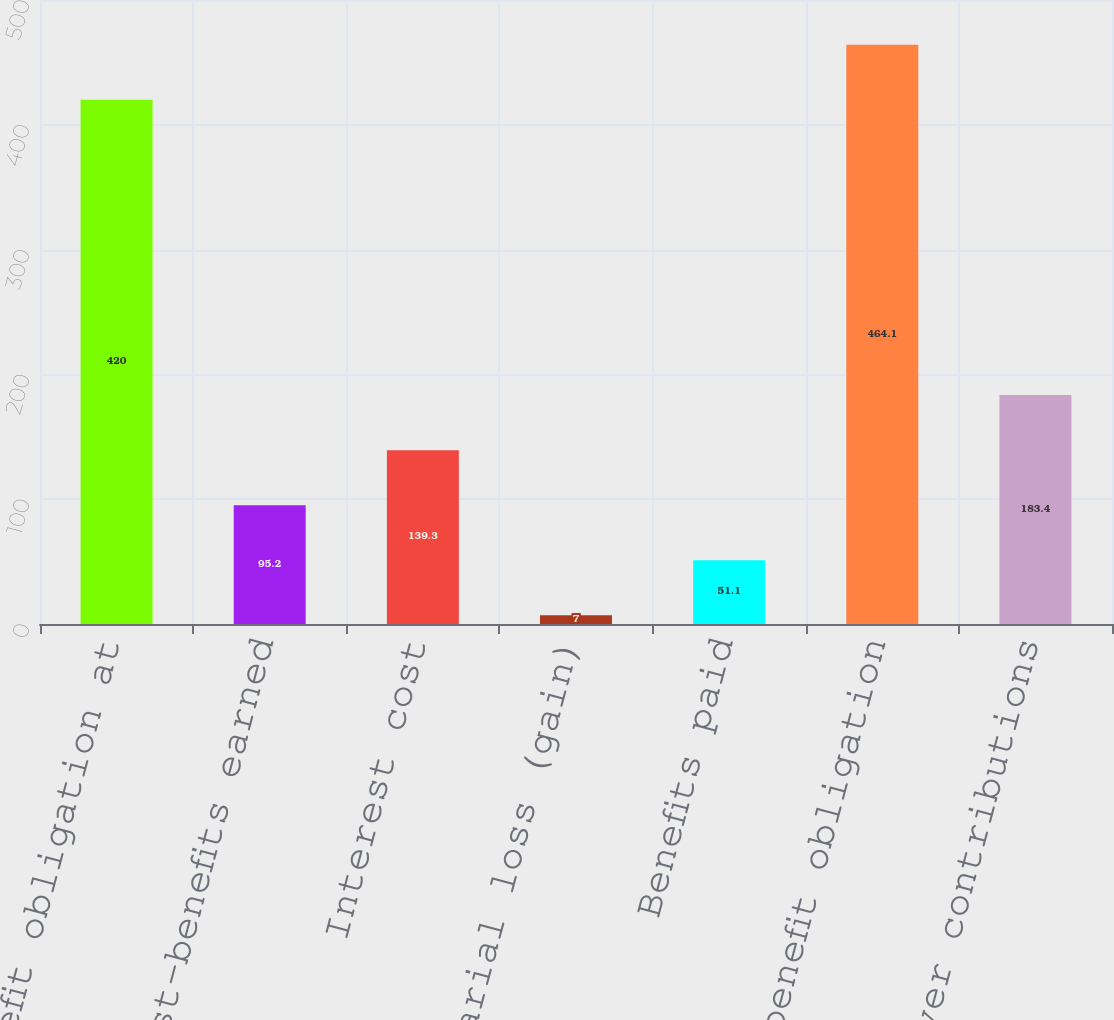Convert chart to OTSL. <chart><loc_0><loc_0><loc_500><loc_500><bar_chart><fcel>Benefit obligation at<fcel>Service cost-benefits earned<fcel>Interest cost<fcel>Actuarial loss (gain)<fcel>Benefits paid<fcel>Projected benefit obligation<fcel>Employer contributions<nl><fcel>420<fcel>95.2<fcel>139.3<fcel>7<fcel>51.1<fcel>464.1<fcel>183.4<nl></chart> 